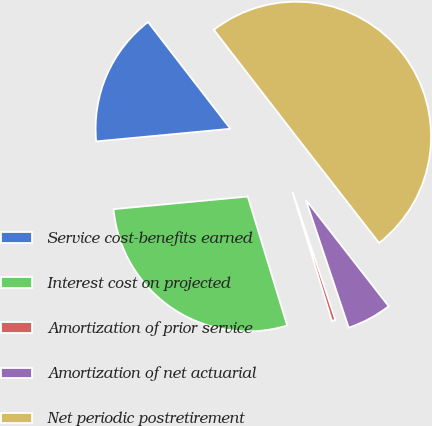Convert chart to OTSL. <chart><loc_0><loc_0><loc_500><loc_500><pie_chart><fcel>Service cost-benefits earned<fcel>Interest cost on projected<fcel>Amortization of prior service<fcel>Amortization of net actuarial<fcel>Net periodic postretirement<nl><fcel>16.03%<fcel>28.23%<fcel>0.43%<fcel>5.38%<fcel>49.94%<nl></chart> 